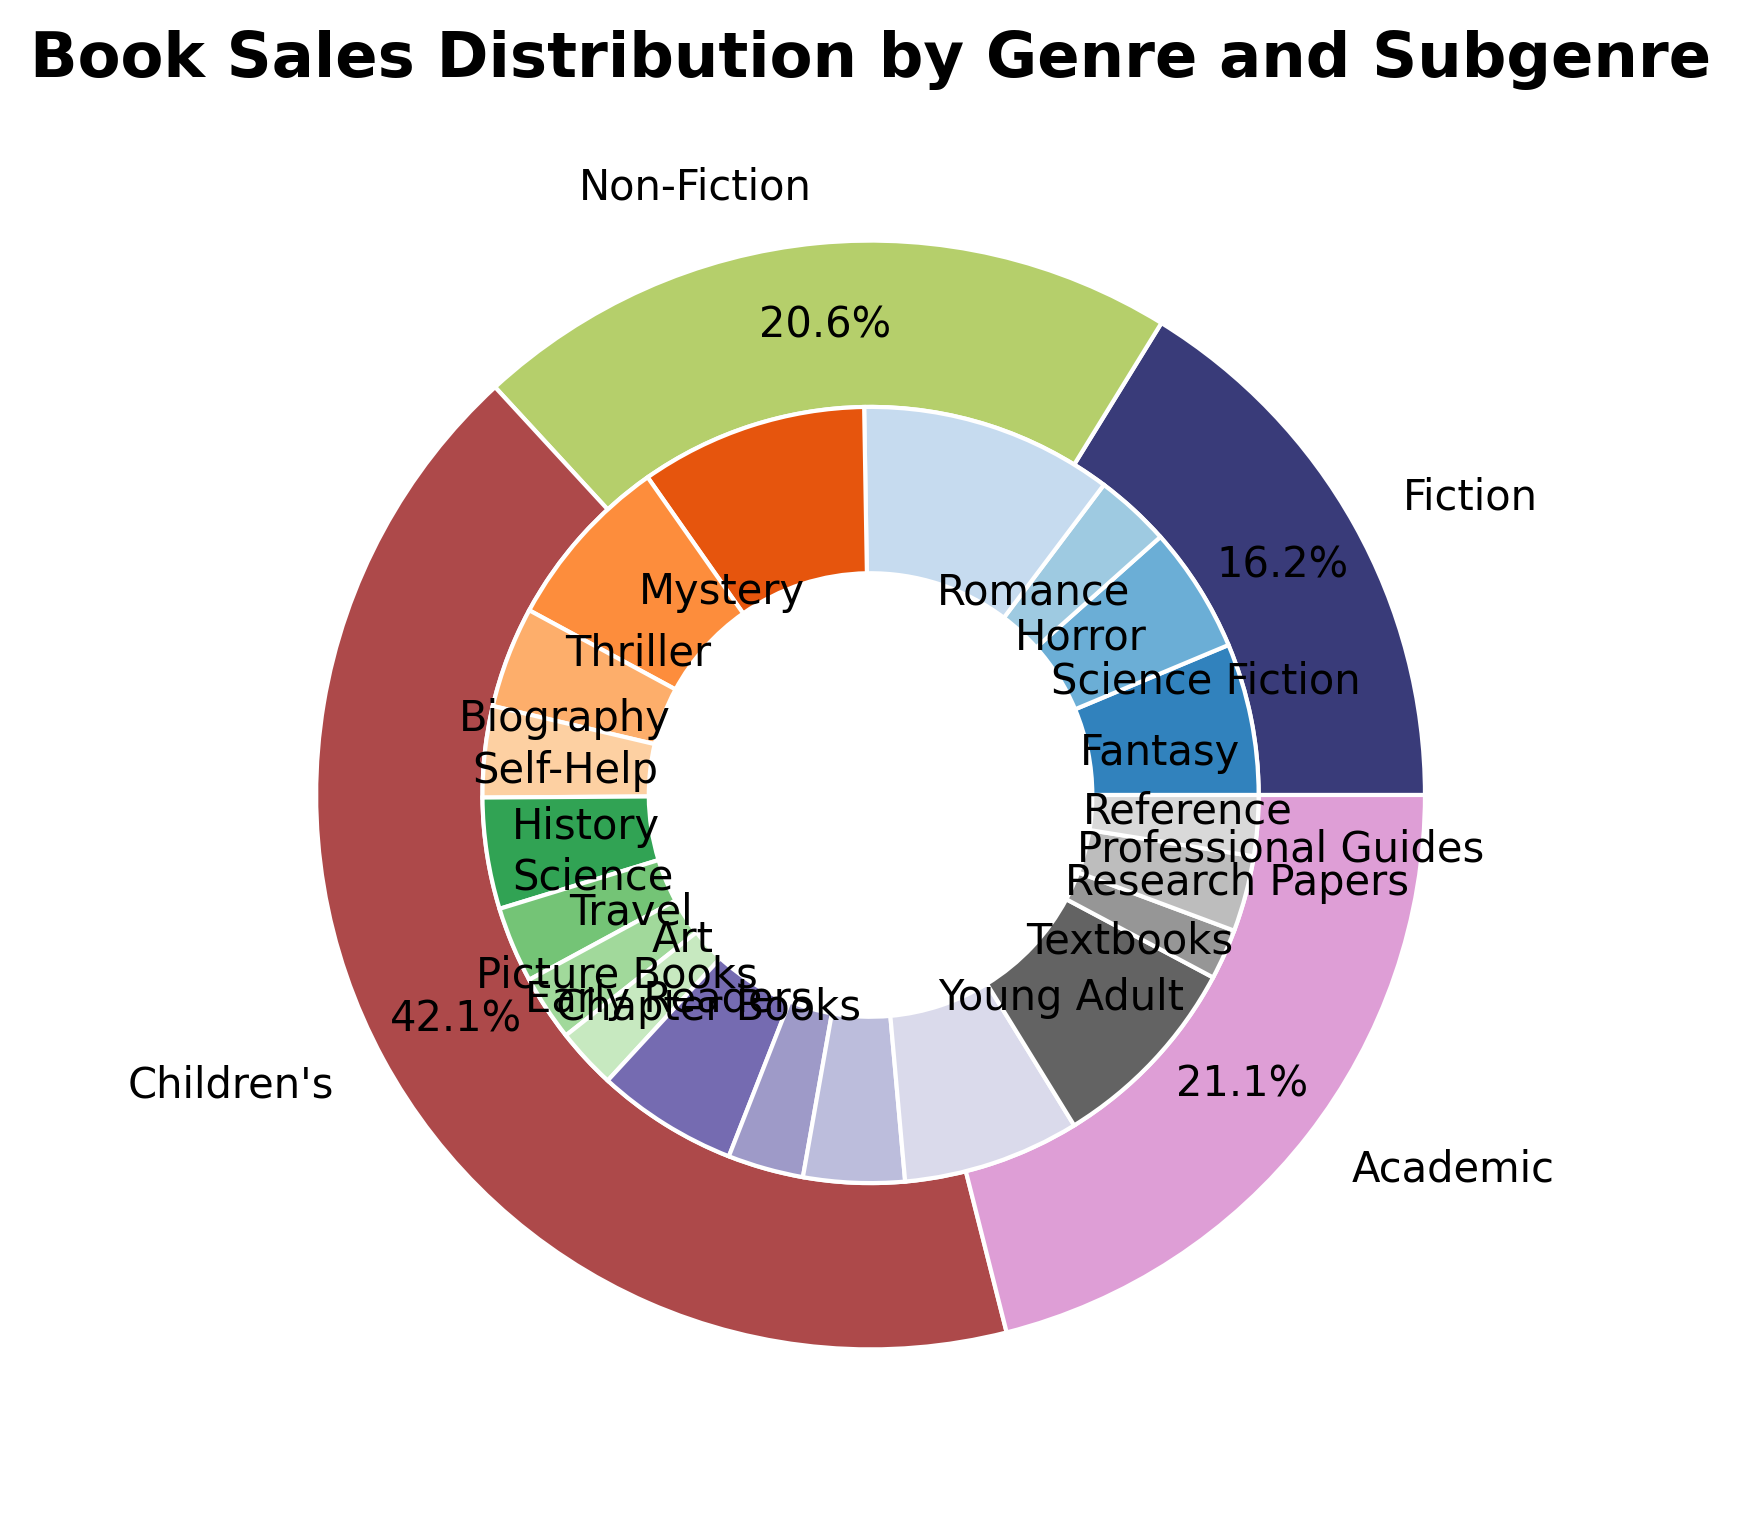Which genre has the highest total book sales? Look at the outer ring of the pie chart for the largest segment. The segment representing Romance in Fiction appears to be the largest, indicating it has the highest total book sales.
Answer: Fiction Between Fantasy and Science Fiction subgenres, which one has more sales? Identify the segments for Fantasy and Science Fiction subgenres in the inner ring. The segment representing Fantasy appears slightly larger.
Answer: Fantasy What are the combined sales of Science Fiction and History subgenres? Find the sales for Science Fiction (25,000) and History (22,000). Add them together to get the total combined sales. 25,000 + 22,000 = 47,000
Answer: 47,000 Which subgenre in Non-Fiction has the lowest sales? Identify the smallest segment in the inner ring for Non-Fiction subgenres. The segment for Art appears to be the smallest.
Answer: Art How does the total sales of Children’s genre compare with Academic genre? Compare the sizes of the outer segments of Children’s and Academic. The segment for Children’s appears larger, indicating it has more total sales than Academic.
Answer: Children’s has more sales What percentage of total book sales does the Mystery subgenre constitute? Find the segment for Mystery in the inner ring and check its percentage. The percentage is labeled on the segment representing Mystery.
Answer: 15% What are the combined sales for the subgenres under Fiction? Sum the sales for Fantasy (30,000), Science Fiction (25,000), Horror (15,000), Romance (50,000), Mystery (45,000), and Thriller (35,000). Total is 30,000 + 25,000 + 15,000 + 50,000 + 45,000 + 35,000 = 200,000.
Answer: 200,000 Which genre shows more diversity in subgenre sales based on the pie chart? Compare the inner segments for each genre to see which one has more evenly distributed subsegments. Genre with diverse subgenre sales will have inner segments closely sized.
Answer: Children's Which genre has the least total book sales? Look at the outer ring for the smallest segment. The segment for Non-Fiction appears the smallest, indicating it has the least total book sales.
Answer: Academic 